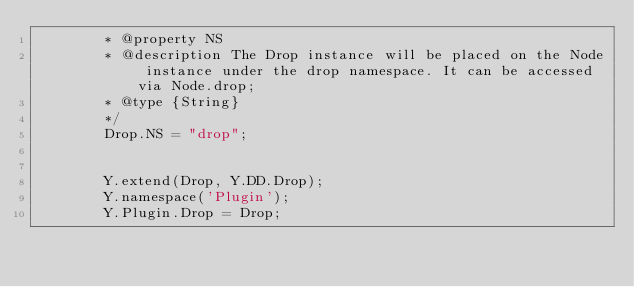<code> <loc_0><loc_0><loc_500><loc_500><_JavaScript_>        * @property NS
        * @description The Drop instance will be placed on the Node instance under the drop namespace. It can be accessed via Node.drop;
        * @type {String}
        */
        Drop.NS = "drop";


        Y.extend(Drop, Y.DD.Drop);
        Y.namespace('Plugin');
        Y.Plugin.Drop = Drop;


</code> 